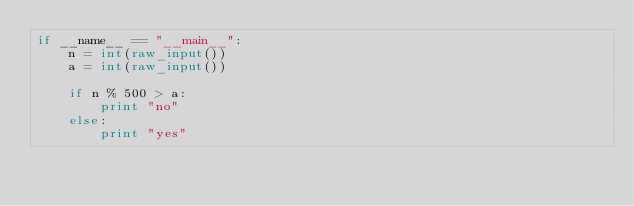Convert code to text. <code><loc_0><loc_0><loc_500><loc_500><_Python_>if __name__ == "__main__":
    n = int(raw_input())
    a = int(raw_input())

    if n % 500 > a:
        print "no"
    else:
        print "yes"
</code> 